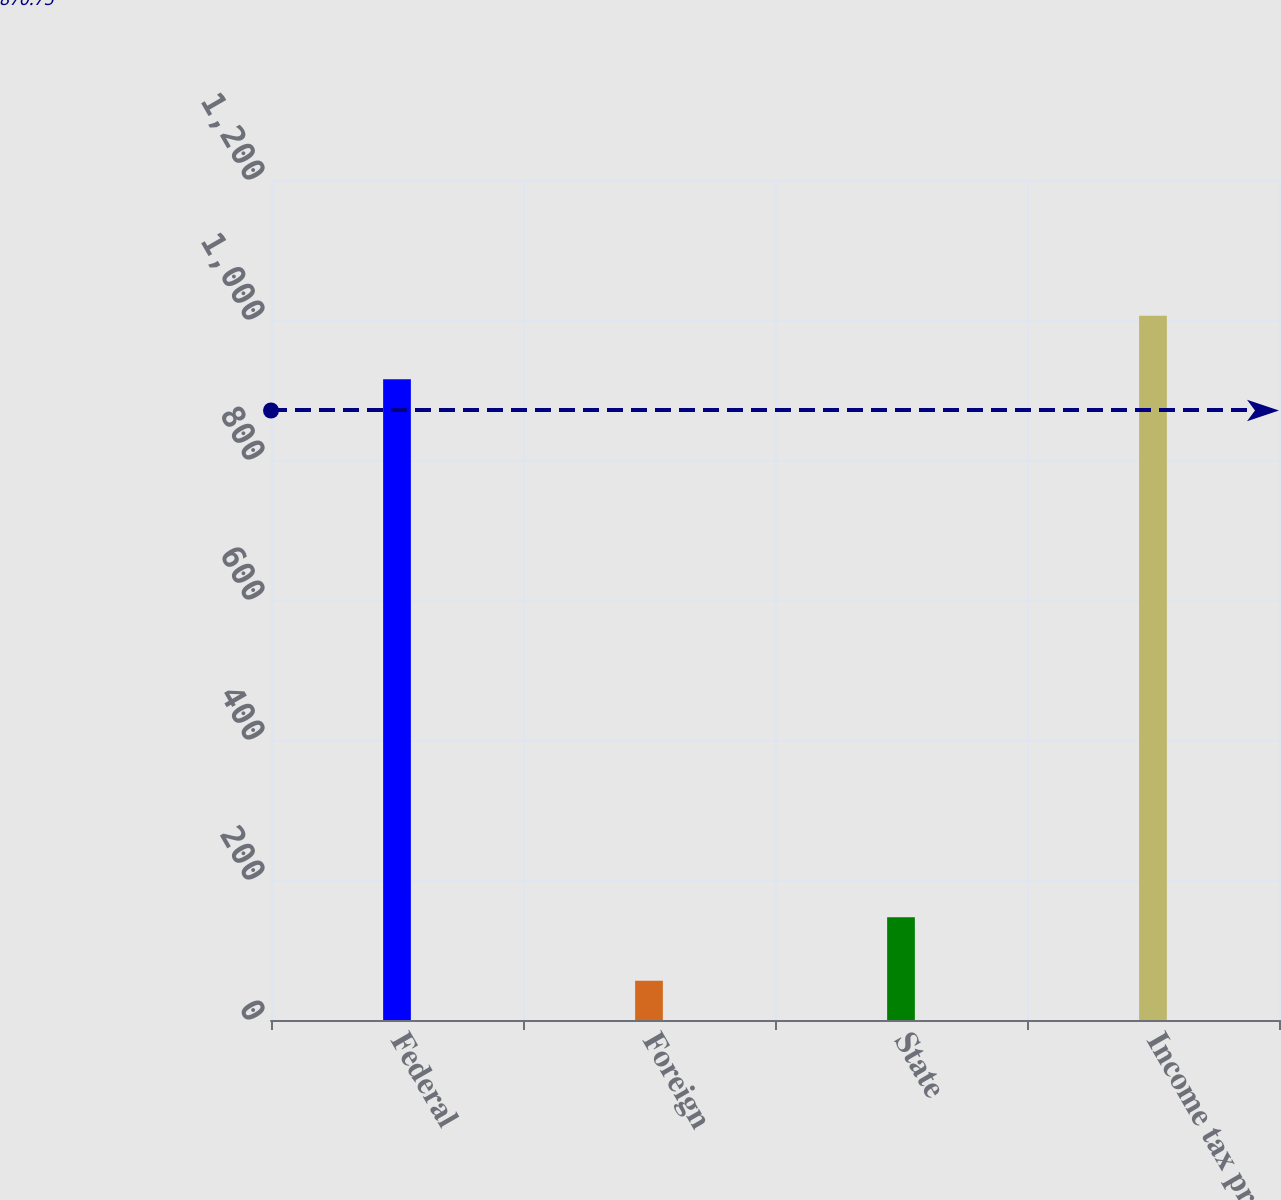Convert chart. <chart><loc_0><loc_0><loc_500><loc_500><bar_chart><fcel>Federal<fcel>Foreign<fcel>State<fcel>Income tax provision<nl><fcel>915.4<fcel>56<fcel>146.82<fcel>1006.22<nl></chart> 